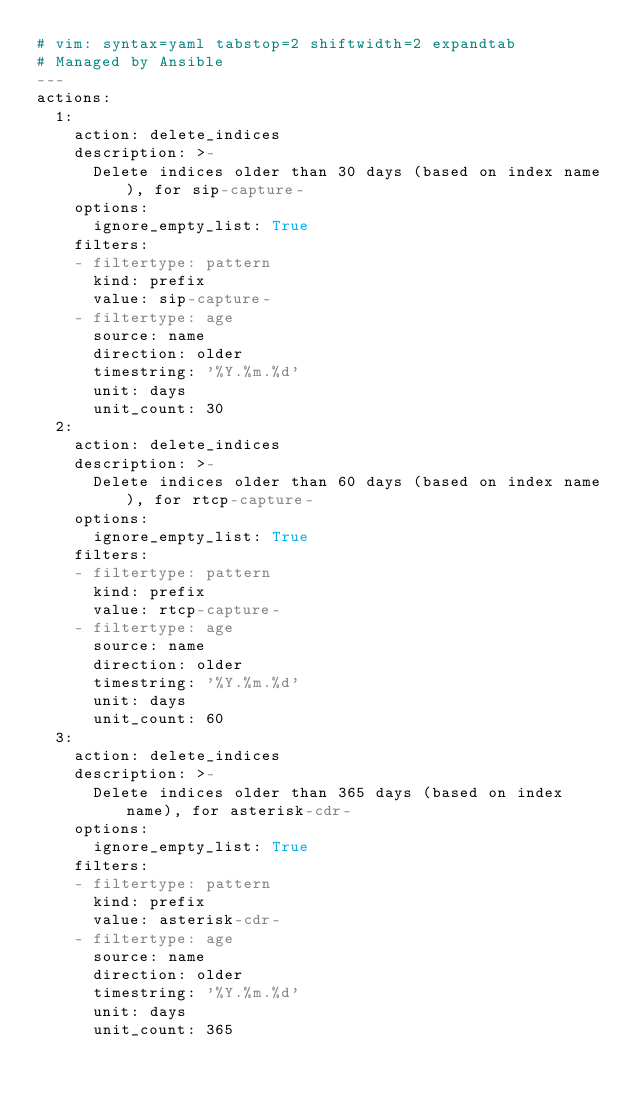<code> <loc_0><loc_0><loc_500><loc_500><_YAML_># vim: syntax=yaml tabstop=2 shiftwidth=2 expandtab
# Managed by Ansible
---
actions:
  1:
    action: delete_indices
    description: >-
      Delete indices older than 30 days (based on index name), for sip-capture-
    options:
      ignore_empty_list: True
    filters:
    - filtertype: pattern
      kind: prefix
      value: sip-capture-
    - filtertype: age
      source: name
      direction: older
      timestring: '%Y.%m.%d'
      unit: days
      unit_count: 30
  2:
    action: delete_indices
    description: >-
      Delete indices older than 60 days (based on index name), for rtcp-capture-
    options:
      ignore_empty_list: True
    filters:
    - filtertype: pattern
      kind: prefix
      value: rtcp-capture-
    - filtertype: age
      source: name
      direction: older
      timestring: '%Y.%m.%d'
      unit: days
      unit_count: 60
  3:
    action: delete_indices
    description: >-
      Delete indices older than 365 days (based on index name), for asterisk-cdr-
    options:
      ignore_empty_list: True
    filters:
    - filtertype: pattern
      kind: prefix
      value: asterisk-cdr-
    - filtertype: age
      source: name
      direction: older
      timestring: '%Y.%m.%d'
      unit: days
      unit_count: 365
</code> 